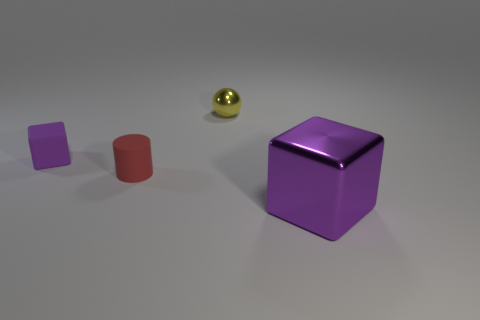Is there anything else of the same color as the small cube?
Offer a very short reply. Yes. What number of big things are cubes or red matte cylinders?
Ensure brevity in your answer.  1. There is a matte thing right of the purple block that is behind the block that is to the right of the sphere; what size is it?
Your answer should be compact. Small. How many red rubber things are the same size as the yellow sphere?
Make the answer very short. 1. How many things are either large yellow metal cubes or shiny things that are in front of the small yellow shiny thing?
Make the answer very short. 1. The purple matte thing is what shape?
Offer a terse response. Cube. Do the ball and the rubber cylinder have the same color?
Make the answer very short. No. What is the color of the matte cylinder that is the same size as the purple rubber thing?
Provide a short and direct response. Red. What number of red objects are either blocks or shiny cubes?
Your response must be concise. 0. Are there more tiny green cylinders than yellow things?
Give a very brief answer. No. 